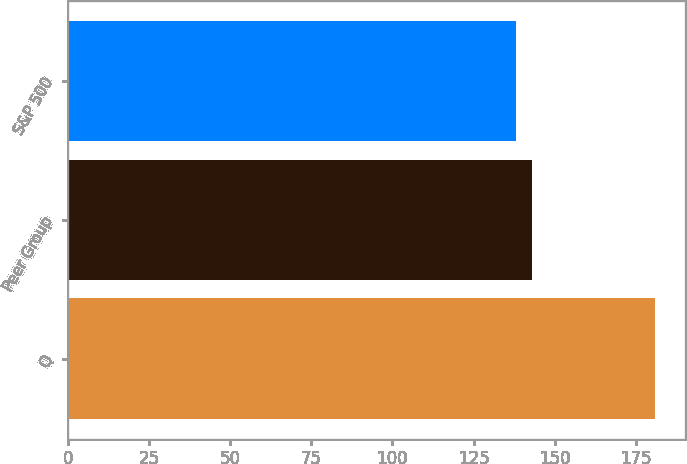<chart> <loc_0><loc_0><loc_500><loc_500><bar_chart><fcel>Q<fcel>Peer Group<fcel>S&P 500<nl><fcel>181<fcel>143<fcel>138<nl></chart> 